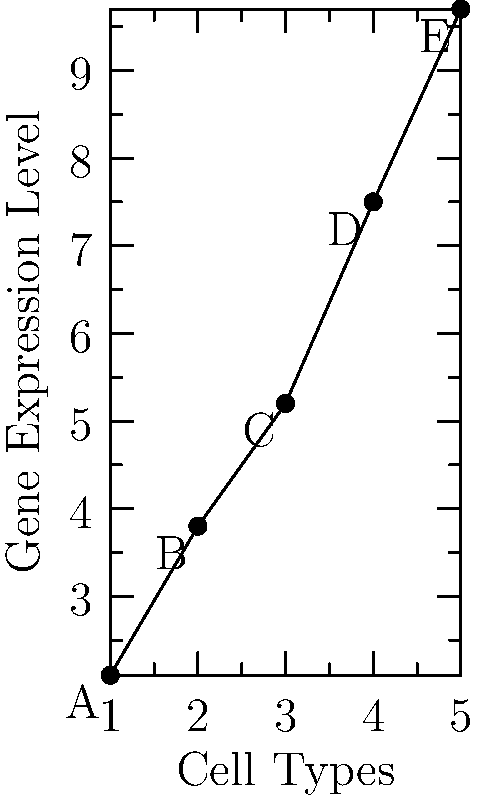In a gene editing study, you're analyzing the expression levels of a specific gene across different cell types. The scatter plot shows the gene expression levels for five cell types (A, B, C, D, and E). What is the correlation coefficient ($r$) between the cell type number and gene expression level, rounded to two decimal places? To calculate the correlation coefficient, we'll use the Pearson correlation formula:

$r = \frac{\sum_{i=1}^{n} (x_i - \bar{x})(y_i - \bar{y})}{\sqrt{\sum_{i=1}^{n} (x_i - \bar{x})^2 \sum_{i=1}^{n} (y_i - \bar{y})^2}}$

Where:
$x_i$ = cell type number
$y_i$ = gene expression level
$\bar{x}$ = mean of cell type numbers
$\bar{y}$ = mean of gene expression levels

Step 1: Calculate means
$\bar{x} = (1 + 2 + 3 + 4 + 5) / 5 = 3$
$\bar{y} = (2.1 + 3.8 + 5.2 + 7.5 + 9.7) / 5 = 5.66$

Step 2: Calculate $(x_i - \bar{x})$ and $(y_i - \bar{y})$ for each point
$(x_1 - \bar{x}) = 1 - 3 = -2$, $(y_1 - \bar{y}) = 2.1 - 5.66 = -3.56$
$(x_2 - \bar{x}) = 2 - 3 = -1$, $(y_2 - \bar{y}) = 3.8 - 5.66 = -1.86$
$(x_3 - \bar{x}) = 3 - 3 = 0$, $(y_3 - \bar{y}) = 5.2 - 5.66 = -0.46$
$(x_4 - \bar{x}) = 4 - 3 = 1$, $(y_4 - \bar{y}) = 7.5 - 5.66 = 1.84$
$(x_5 - \bar{x}) = 5 - 3 = 2$, $(y_5 - \bar{y}) = 9.7 - 5.66 = 4.04$

Step 3: Calculate the numerator and denominator
Numerator: $\sum (x_i - \bar{x})(y_i - \bar{y}) = 7.12 + 1.86 + 0 + 1.84 + 8.08 = 18.9$
Denominator: $\sqrt{\sum (x_i - \bar{x})^2 \sum (y_i - \bar{y})^2} = \sqrt{(4 + 1 + 0 + 1 + 4) \times (12.6736 + 3.4596 + 0.2116 + 3.3856 + 16.3216)} = \sqrt{10 \times 36.052} = 18.98$

Step 4: Calculate $r$
$r = 18.9 / 18.98 = 0.9957$

Step 5: Round to two decimal places
$r \approx 1.00$
Answer: 1.00 